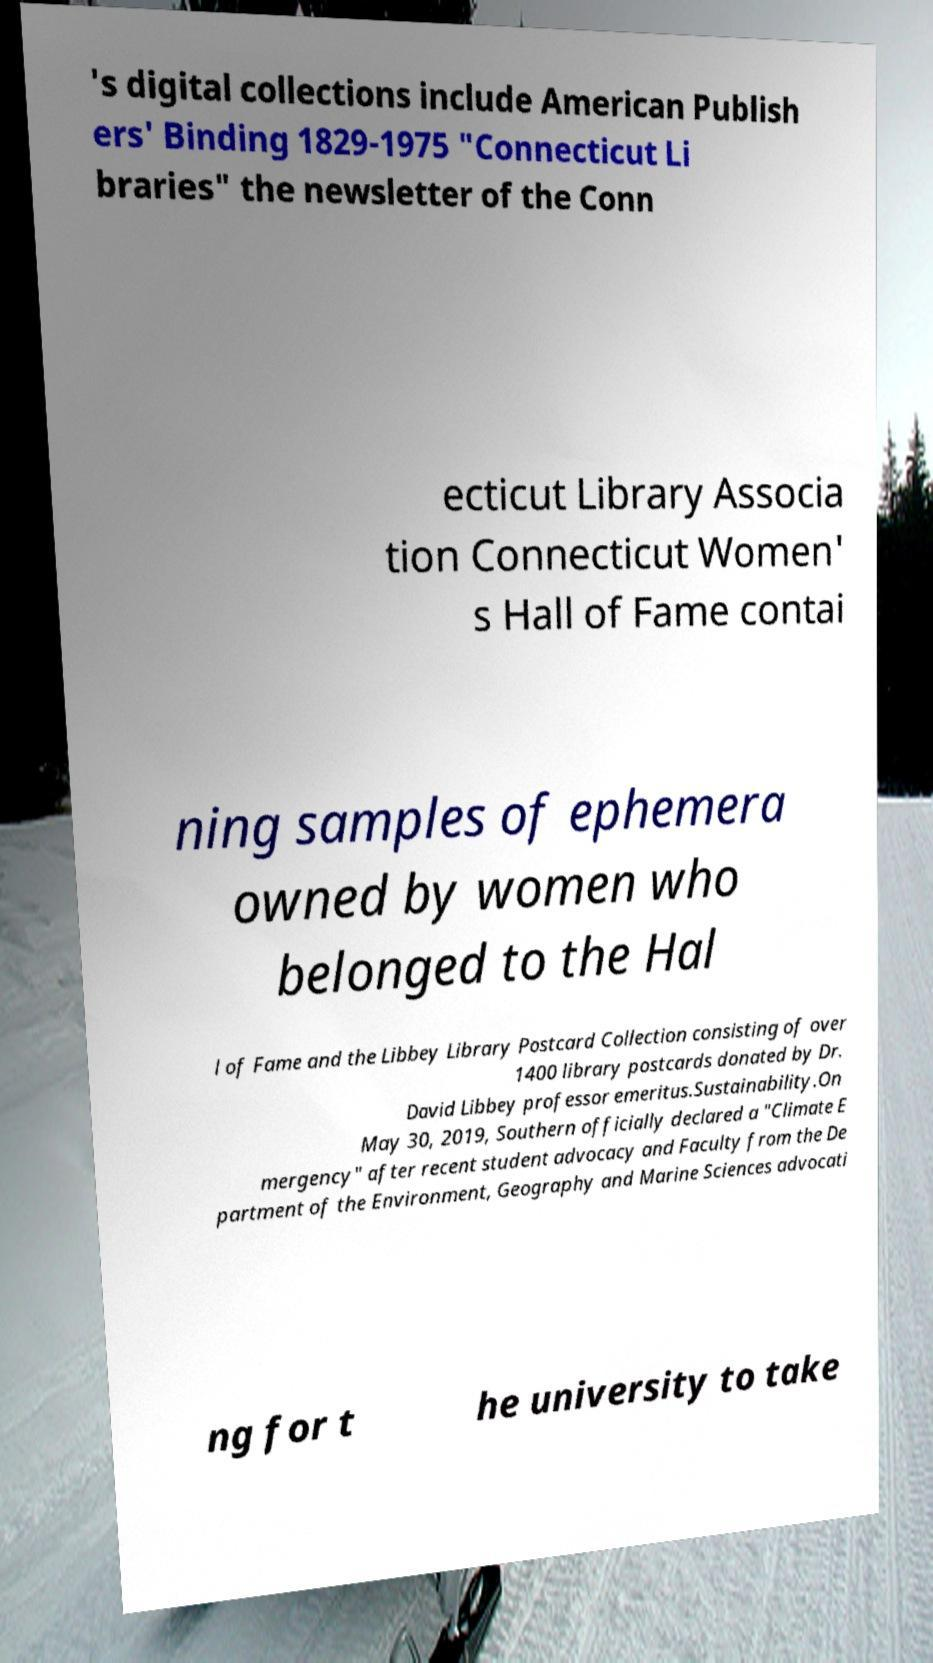For documentation purposes, I need the text within this image transcribed. Could you provide that? 's digital collections include American Publish ers' Binding 1829-1975 "Connecticut Li braries" the newsletter of the Conn ecticut Library Associa tion Connecticut Women' s Hall of Fame contai ning samples of ephemera owned by women who belonged to the Hal l of Fame and the Libbey Library Postcard Collection consisting of over 1400 library postcards donated by Dr. David Libbey professor emeritus.Sustainability.On May 30, 2019, Southern officially declared a "Climate E mergency" after recent student advocacy and Faculty from the De partment of the Environment, Geography and Marine Sciences advocati ng for t he university to take 